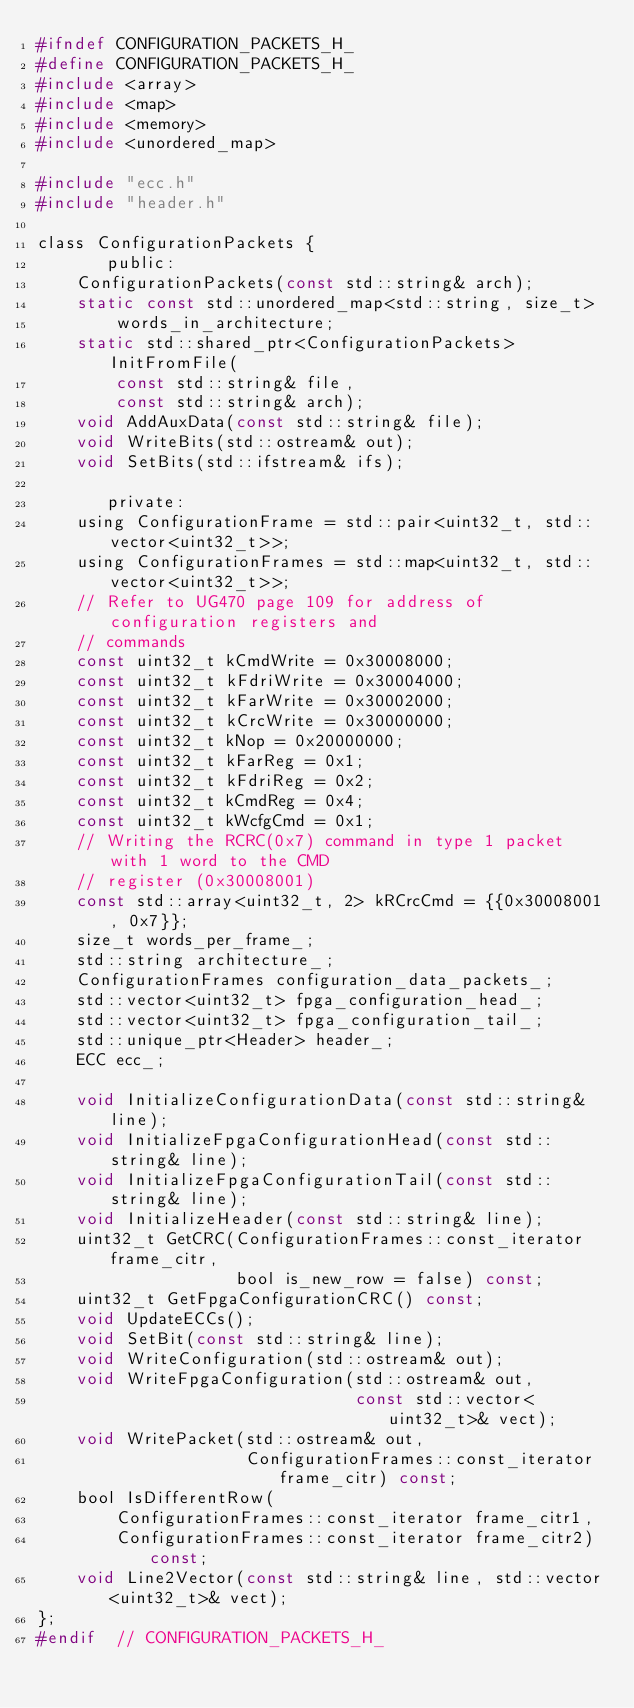<code> <loc_0><loc_0><loc_500><loc_500><_C_>#ifndef CONFIGURATION_PACKETS_H_
#define CONFIGURATION_PACKETS_H_
#include <array>
#include <map>
#include <memory>
#include <unordered_map>

#include "ecc.h"
#include "header.h"

class ConfigurationPackets {
       public:
	ConfigurationPackets(const std::string& arch);
	static const std::unordered_map<std::string, size_t>
	    words_in_architecture;
	static std::shared_ptr<ConfigurationPackets> InitFromFile(
	    const std::string& file,
	    const std::string& arch);
	void AddAuxData(const std::string& file);
	void WriteBits(std::ostream& out);
	void SetBits(std::ifstream& ifs);

       private:
	using ConfigurationFrame = std::pair<uint32_t, std::vector<uint32_t>>;
	using ConfigurationFrames = std::map<uint32_t, std::vector<uint32_t>>;
	// Refer to UG470 page 109 for address of configuration registers and
	// commands
	const uint32_t kCmdWrite = 0x30008000;
	const uint32_t kFdriWrite = 0x30004000;
	const uint32_t kFarWrite = 0x30002000;
	const uint32_t kCrcWrite = 0x30000000;
	const uint32_t kNop = 0x20000000;
	const uint32_t kFarReg = 0x1;
	const uint32_t kFdriReg = 0x2;
	const uint32_t kCmdReg = 0x4;
	const uint32_t kWcfgCmd = 0x1;
	// Writing the RCRC(0x7) command in type 1 packet with 1 word to the CMD
	// register (0x30008001)
	const std::array<uint32_t, 2> kRCrcCmd = {{0x30008001, 0x7}};
	size_t words_per_frame_;
	std::string architecture_;
	ConfigurationFrames configuration_data_packets_;
	std::vector<uint32_t> fpga_configuration_head_;
	std::vector<uint32_t> fpga_configuration_tail_;
	std::unique_ptr<Header> header_;
	ECC ecc_;

	void InitializeConfigurationData(const std::string& line);
	void InitializeFpgaConfigurationHead(const std::string& line);
	void InitializeFpgaConfigurationTail(const std::string& line);
	void InitializeHeader(const std::string& line);
	uint32_t GetCRC(ConfigurationFrames::const_iterator frame_citr,
	                bool is_new_row = false) const;
	uint32_t GetFpgaConfigurationCRC() const;
	void UpdateECCs();
	void SetBit(const std::string& line);
	void WriteConfiguration(std::ostream& out);
	void WriteFpgaConfiguration(std::ostream& out,
	                            const std::vector<uint32_t>& vect);
	void WritePacket(std::ostream& out,
	                 ConfigurationFrames::const_iterator frame_citr) const;
	bool IsDifferentRow(
	    ConfigurationFrames::const_iterator frame_citr1,
	    ConfigurationFrames::const_iterator frame_citr2) const;
	void Line2Vector(const std::string& line, std::vector<uint32_t>& vect);
};
#endif  // CONFIGURATION_PACKETS_H_
</code> 